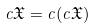Convert formula to latex. <formula><loc_0><loc_0><loc_500><loc_500>c { \mathfrak { X } } = c ( c { \mathfrak { X } } )</formula> 